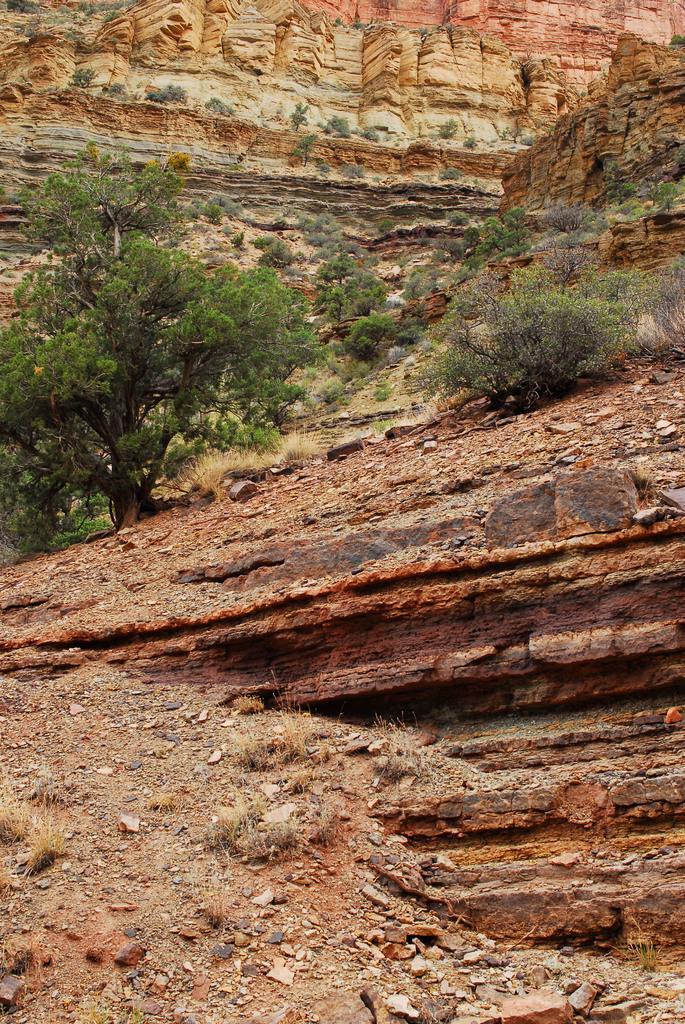How would you summarize this image in a sentence or two? In this image, we can see trees, plants and hills. 